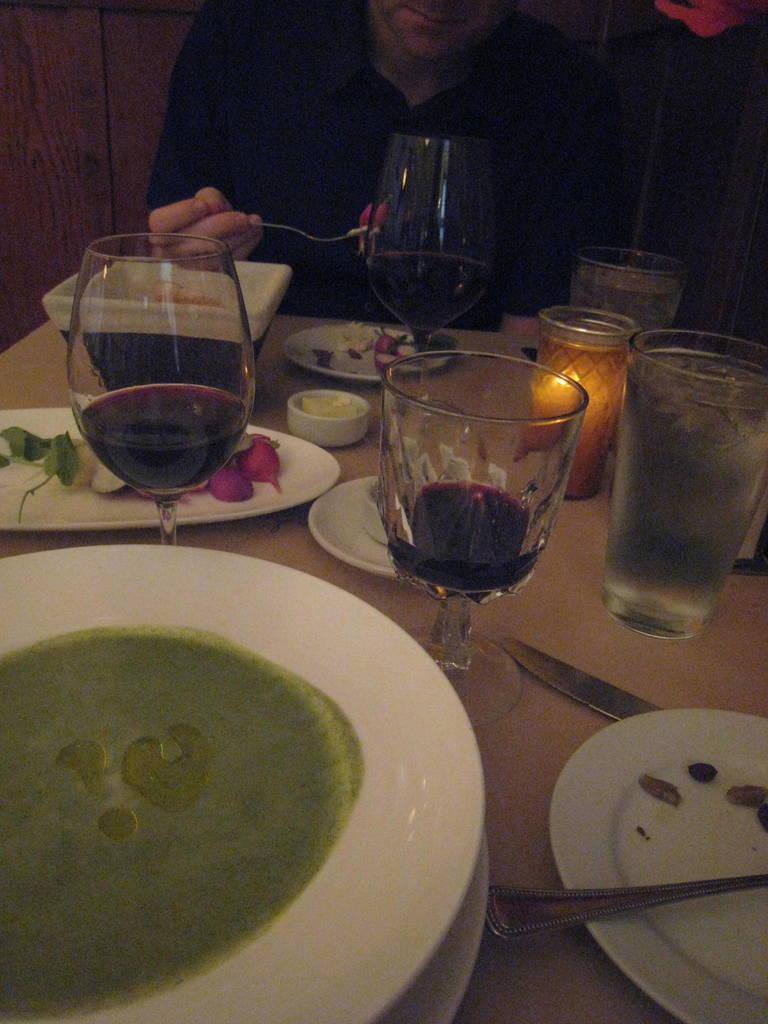Who is present in the image? There is a man in the image. What is the man doing in the image? The man is having food in the image. Where is the man located in the image? The man is at a table in the image. What objects are on the table with the man? There are glasses and plates on the table in the image. What degree does the yam have in the image? There is no yam present in the image, so it is not possible to determine its degree. 